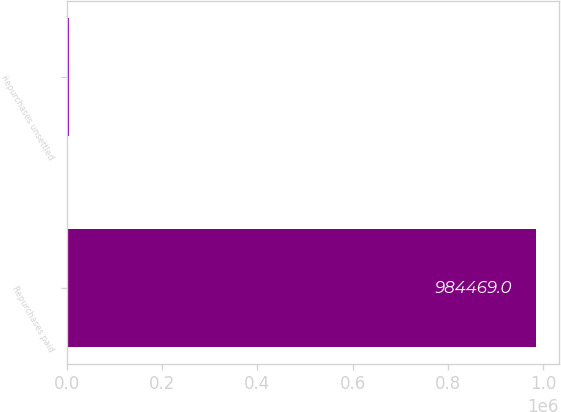Convert chart. <chart><loc_0><loc_0><loc_500><loc_500><bar_chart><fcel>Repurchases paid<fcel>Repurchases unsettled<nl><fcel>984469<fcel>3362<nl></chart> 